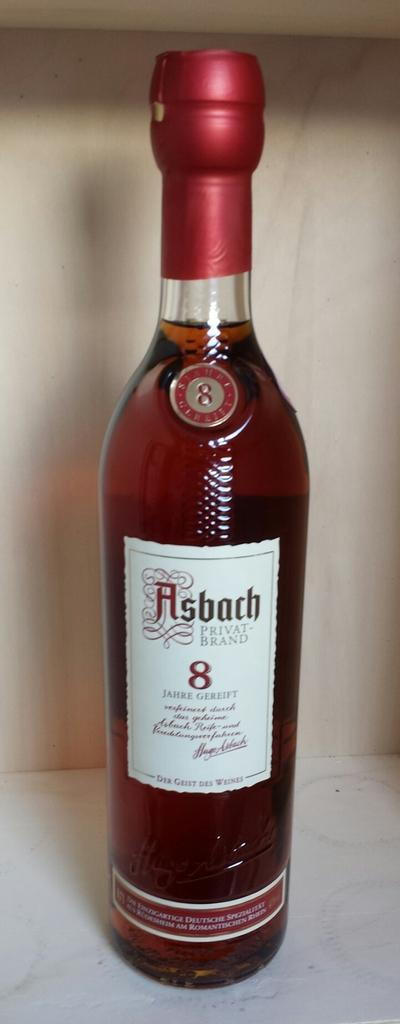<image>
Present a compact description of the photo's key features. A bottle of Asbach Private Brand brandy is center on a lightly colored background. 